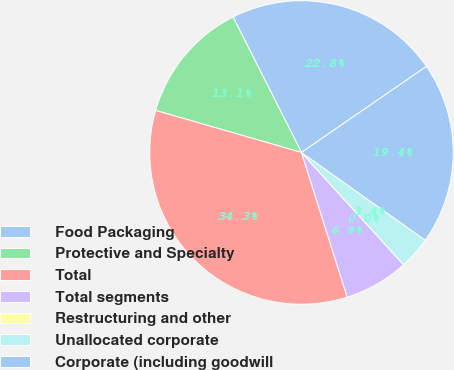<chart> <loc_0><loc_0><loc_500><loc_500><pie_chart><fcel>Food Packaging<fcel>Protective and Specialty<fcel>Total<fcel>Total segments<fcel>Restructuring and other<fcel>Unallocated corporate<fcel>Corporate (including goodwill<nl><fcel>22.84%<fcel>13.09%<fcel>34.34%<fcel>6.87%<fcel>0.0%<fcel>3.44%<fcel>19.41%<nl></chart> 